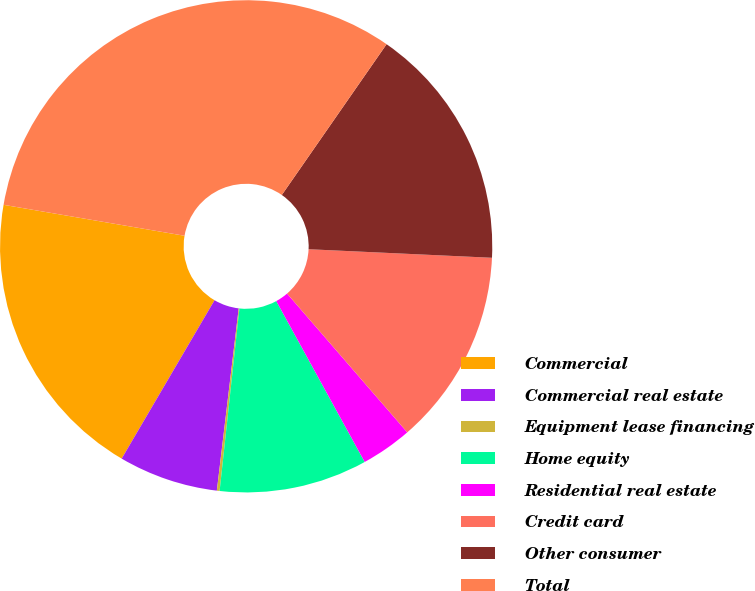Convert chart to OTSL. <chart><loc_0><loc_0><loc_500><loc_500><pie_chart><fcel>Commercial<fcel>Commercial real estate<fcel>Equipment lease financing<fcel>Home equity<fcel>Residential real estate<fcel>Credit card<fcel>Other consumer<fcel>Total<nl><fcel>19.26%<fcel>6.54%<fcel>0.18%<fcel>9.72%<fcel>3.36%<fcel>12.9%<fcel>16.08%<fcel>31.97%<nl></chart> 